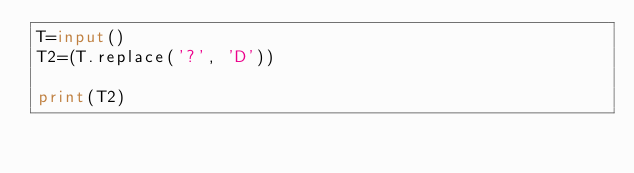Convert code to text. <code><loc_0><loc_0><loc_500><loc_500><_Python_>T=input()
T2=(T.replace('?', 'D'))

print(T2)</code> 